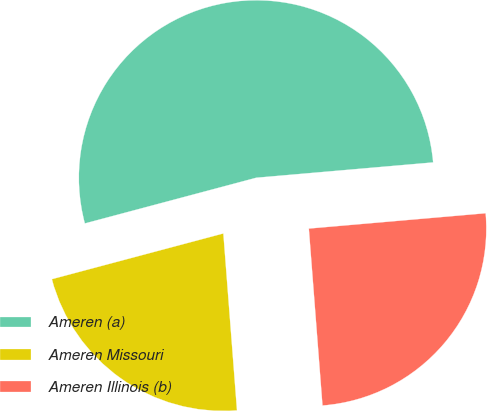<chart> <loc_0><loc_0><loc_500><loc_500><pie_chart><fcel>Ameren (a)<fcel>Ameren Missouri<fcel>Ameren Illinois (b)<nl><fcel>52.77%<fcel>22.08%<fcel>25.15%<nl></chart> 